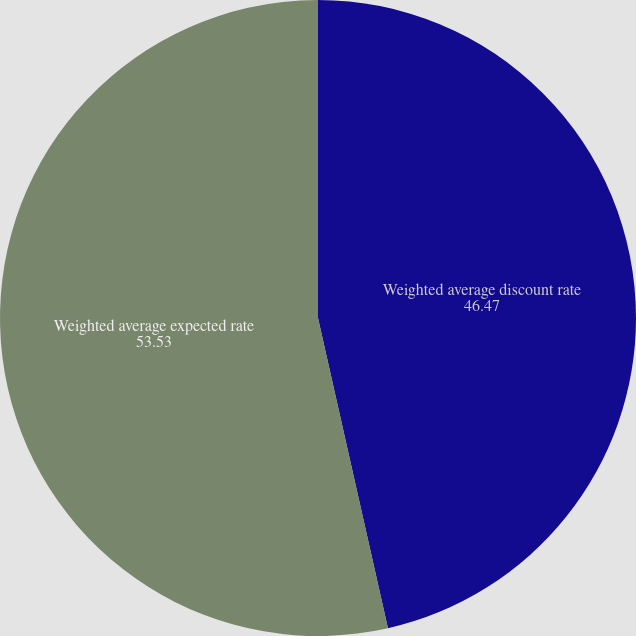Convert chart. <chart><loc_0><loc_0><loc_500><loc_500><pie_chart><fcel>Weighted average discount rate<fcel>Weighted average expected rate<nl><fcel>46.47%<fcel>53.53%<nl></chart> 